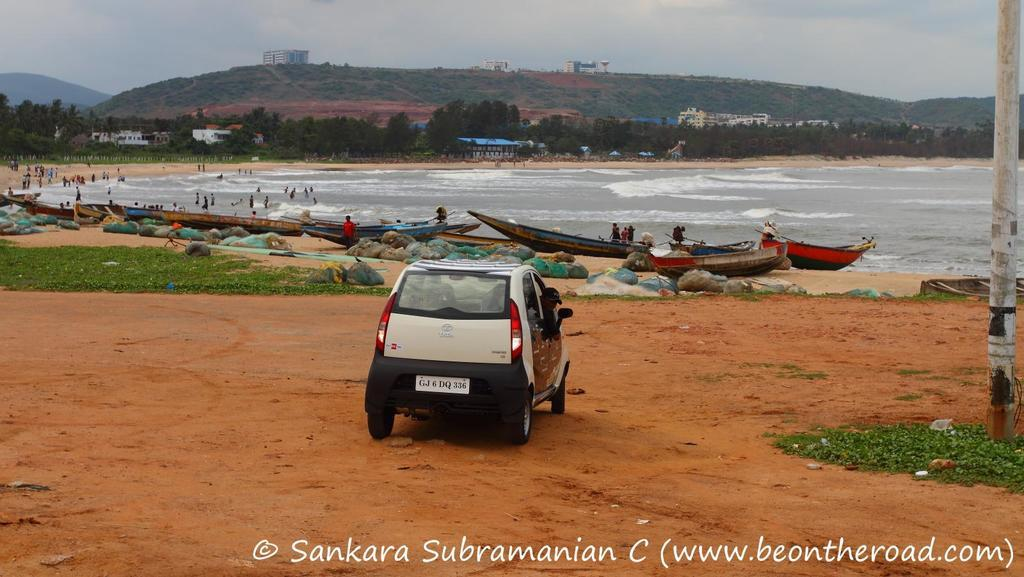What is the main subject of the image? The main subject of the image is a car. What type of natural environment is visible in the image? There is grass, water, trees, and hills visible in the image. What type of structures can be seen in the image? There are buildings visible in the image. What is the sky's condition in the image? The sky is visible in the image. What type of laborer is working on the wall in the image? There is no wall or laborer present in the image. What advice does the father give to the children in the image? There is no father or children present in the image. 